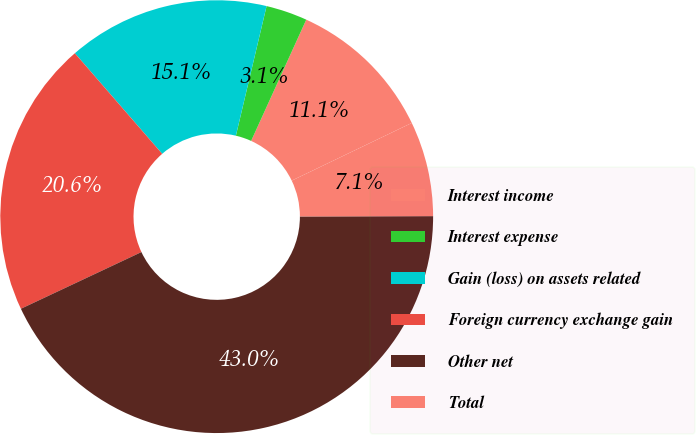Convert chart to OTSL. <chart><loc_0><loc_0><loc_500><loc_500><pie_chart><fcel>Interest income<fcel>Interest expense<fcel>Gain (loss) on assets related<fcel>Foreign currency exchange gain<fcel>Other net<fcel>Total<nl><fcel>11.08%<fcel>3.09%<fcel>15.08%<fcel>20.62%<fcel>43.04%<fcel>7.09%<nl></chart> 